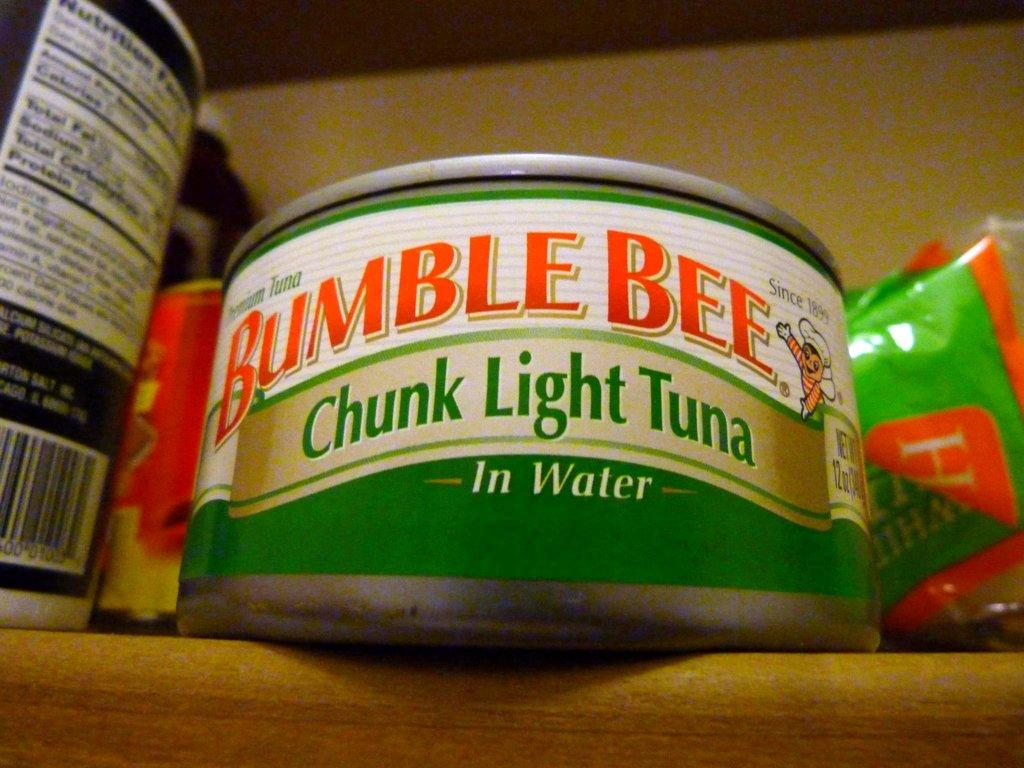<image>
Describe the image concisely. A can of Bumble Bee Chunk Light Tuna in Water. 